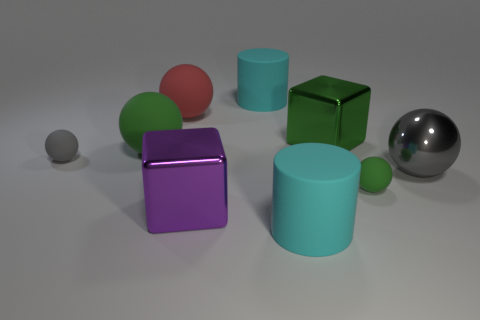What number of tiny spheres are the same color as the big metal ball?
Offer a very short reply. 1. There is a purple cube that is the same size as the metallic ball; what is its material?
Give a very brief answer. Metal. Does the green metal thing have the same shape as the large gray thing?
Your answer should be compact. No. Is there anything else that has the same size as the red rubber object?
Provide a succinct answer. Yes. There is a gray matte ball; how many purple metallic objects are on the right side of it?
Give a very brief answer. 1. There is a rubber object in front of the purple thing; is its size the same as the tiny green rubber thing?
Make the answer very short. No. The large metal thing that is the same shape as the small gray object is what color?
Keep it short and to the point. Gray. Is there anything else that has the same shape as the big purple metal thing?
Your response must be concise. Yes. There is a gray thing right of the big green shiny cube; what shape is it?
Your answer should be very brief. Sphere. How many red matte objects have the same shape as the tiny green rubber thing?
Provide a short and direct response. 1. 